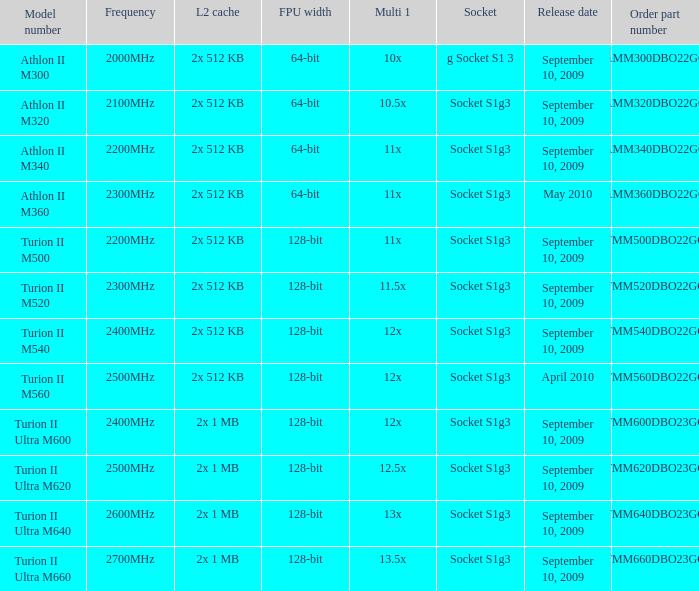What is the level 2 cache with a 1 2x 1 MB. 